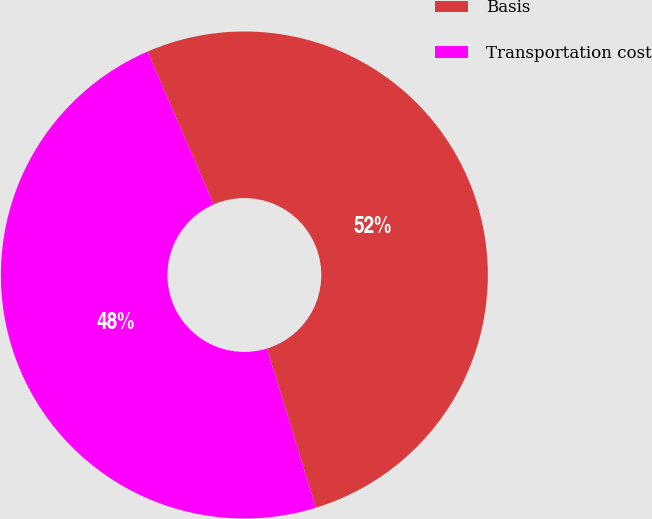Convert chart. <chart><loc_0><loc_0><loc_500><loc_500><pie_chart><fcel>Basis<fcel>Transportation cost<nl><fcel>51.76%<fcel>48.24%<nl></chart> 